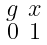Convert formula to latex. <formula><loc_0><loc_0><loc_500><loc_500>\begin{smallmatrix} g & x \\ 0 & 1 \end{smallmatrix}</formula> 